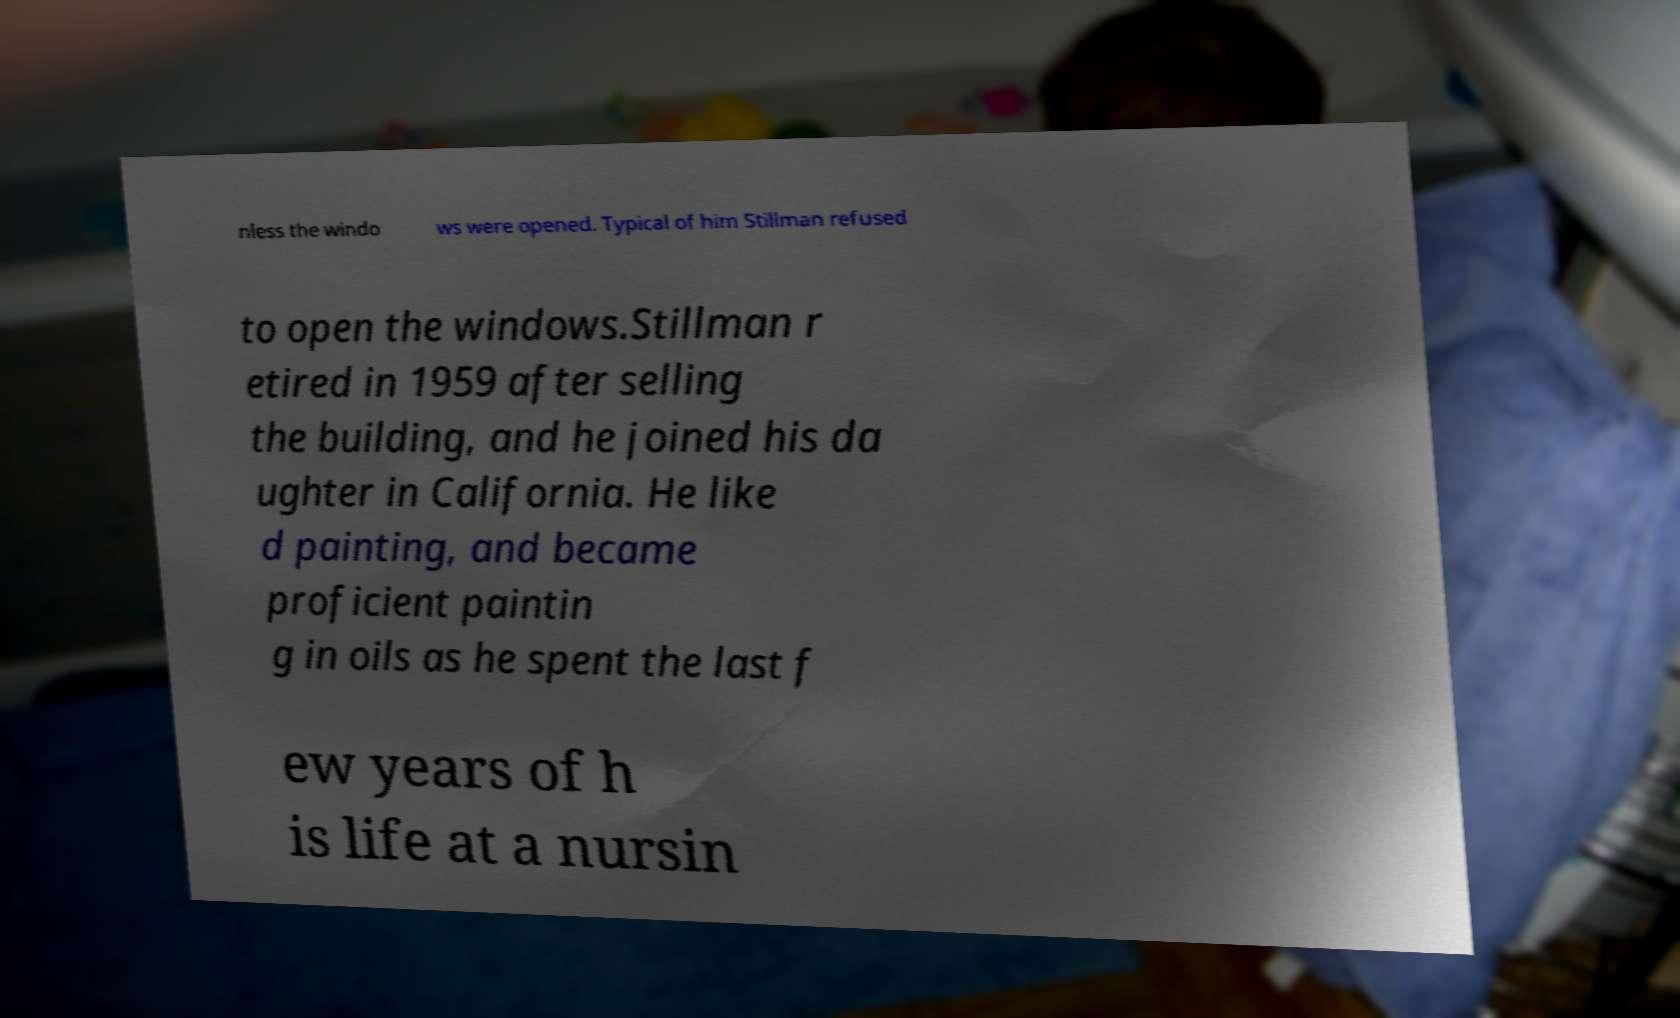Please identify and transcribe the text found in this image. nless the windo ws were opened. Typical of him Stillman refused to open the windows.Stillman r etired in 1959 after selling the building, and he joined his da ughter in California. He like d painting, and became proficient paintin g in oils as he spent the last f ew years of h is life at a nursin 